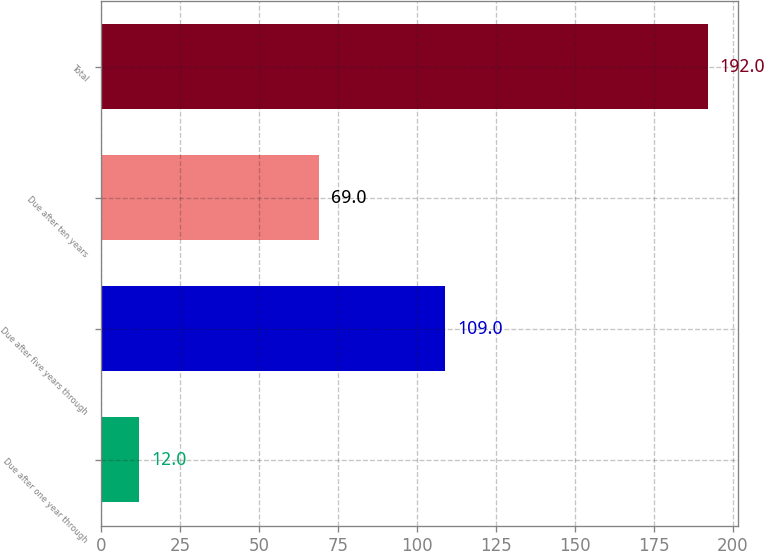Convert chart to OTSL. <chart><loc_0><loc_0><loc_500><loc_500><bar_chart><fcel>Due after one year through<fcel>Due after five years through<fcel>Due after ten years<fcel>Total<nl><fcel>12<fcel>109<fcel>69<fcel>192<nl></chart> 